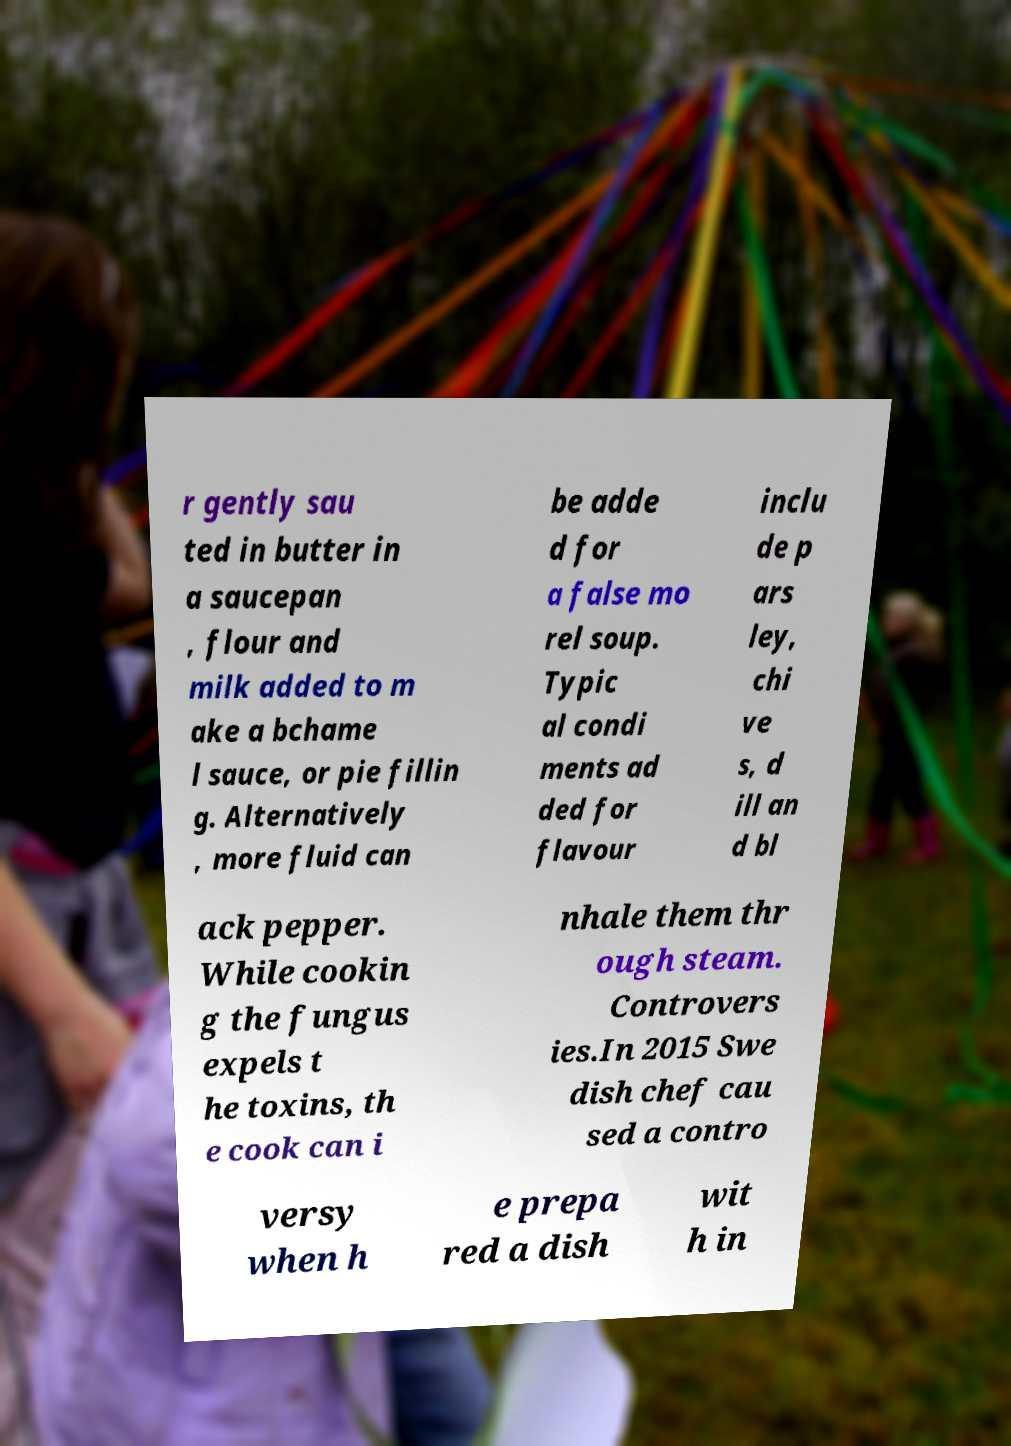Could you extract and type out the text from this image? r gently sau ted in butter in a saucepan , flour and milk added to m ake a bchame l sauce, or pie fillin g. Alternatively , more fluid can be adde d for a false mo rel soup. Typic al condi ments ad ded for flavour inclu de p ars ley, chi ve s, d ill an d bl ack pepper. While cookin g the fungus expels t he toxins, th e cook can i nhale them thr ough steam. Controvers ies.In 2015 Swe dish chef cau sed a contro versy when h e prepa red a dish wit h in 